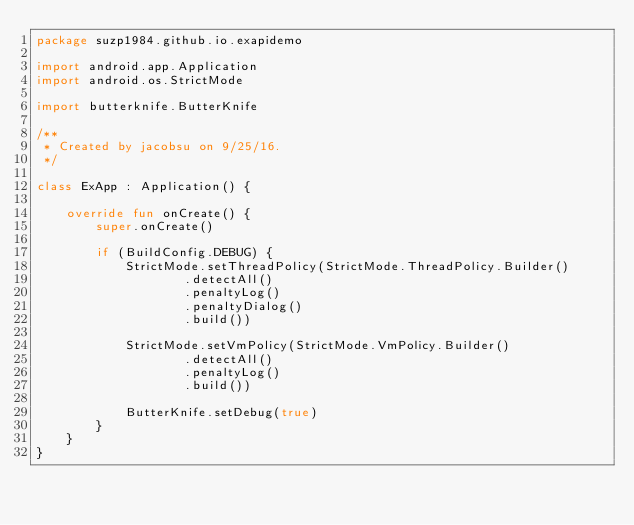<code> <loc_0><loc_0><loc_500><loc_500><_Kotlin_>package suzp1984.github.io.exapidemo

import android.app.Application
import android.os.StrictMode

import butterknife.ButterKnife

/**
 * Created by jacobsu on 9/25/16.
 */

class ExApp : Application() {

    override fun onCreate() {
        super.onCreate()

        if (BuildConfig.DEBUG) {
            StrictMode.setThreadPolicy(StrictMode.ThreadPolicy.Builder()
                    .detectAll()
                    .penaltyLog()
                    .penaltyDialog()
                    .build())

            StrictMode.setVmPolicy(StrictMode.VmPolicy.Builder()
                    .detectAll()
                    .penaltyLog()
                    .build())

            ButterKnife.setDebug(true)
        }
    }
}
</code> 